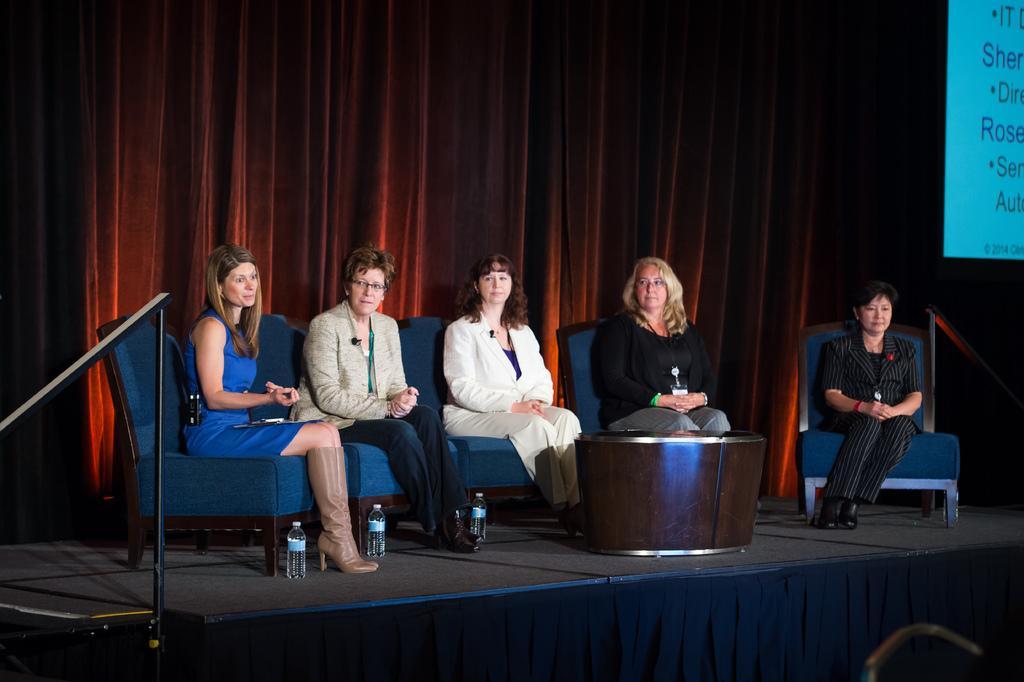Please provide a concise description of this image. In this image we can see five persons sitting on chairs. In front of the persons we can see a table. There are three bottles on the surface. Behind the persons we can see a red cloth. On the right side, we can see a screen with text. 